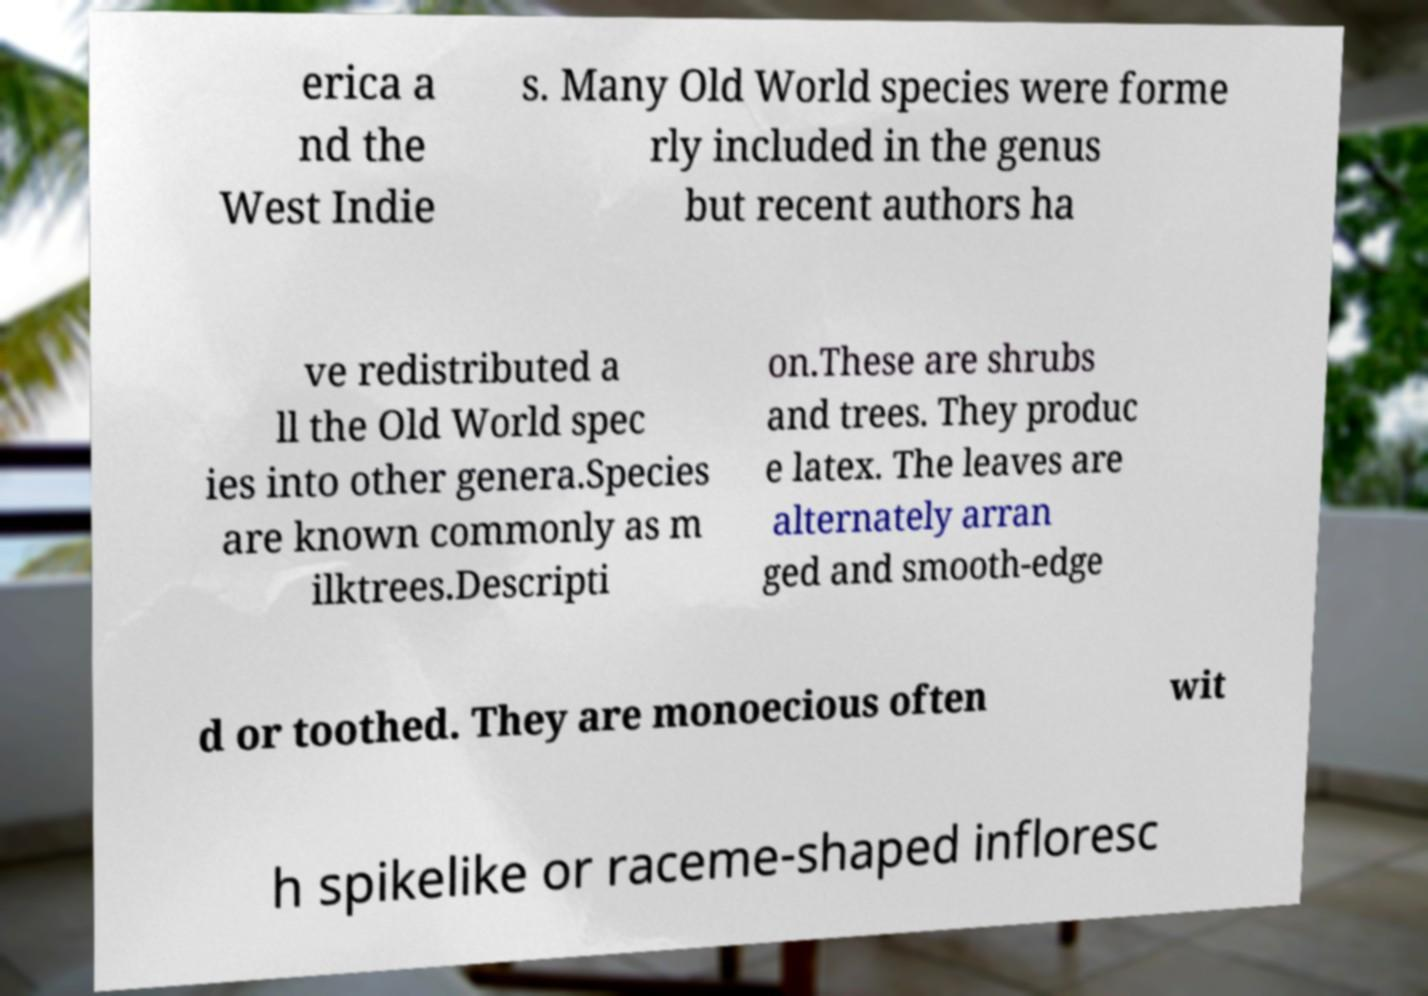Could you extract and type out the text from this image? erica a nd the West Indie s. Many Old World species were forme rly included in the genus but recent authors ha ve redistributed a ll the Old World spec ies into other genera.Species are known commonly as m ilktrees.Descripti on.These are shrubs and trees. They produc e latex. The leaves are alternately arran ged and smooth-edge d or toothed. They are monoecious often wit h spikelike or raceme-shaped infloresc 